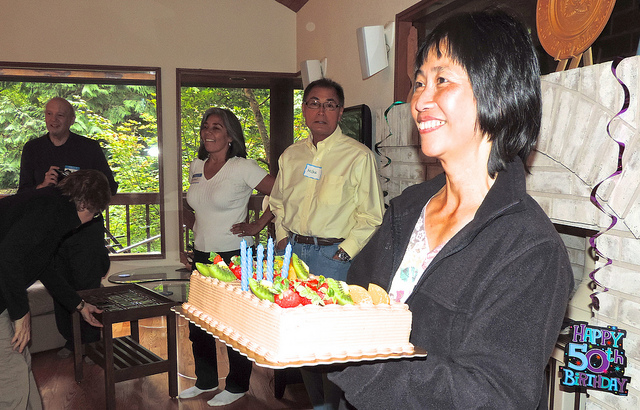Read all the text in this image. HAPPY 50th BiRTHDAY 